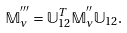<formula> <loc_0><loc_0><loc_500><loc_500>\mathbb { M } ^ { ^ { \prime \prime \prime } } _ { \nu } = { \mathbb { U } } _ { 1 2 } ^ { T } \mathbb { M } ^ { ^ { \prime \prime } } _ { \nu } { \mathbb { U } } _ { 1 2 } .</formula> 